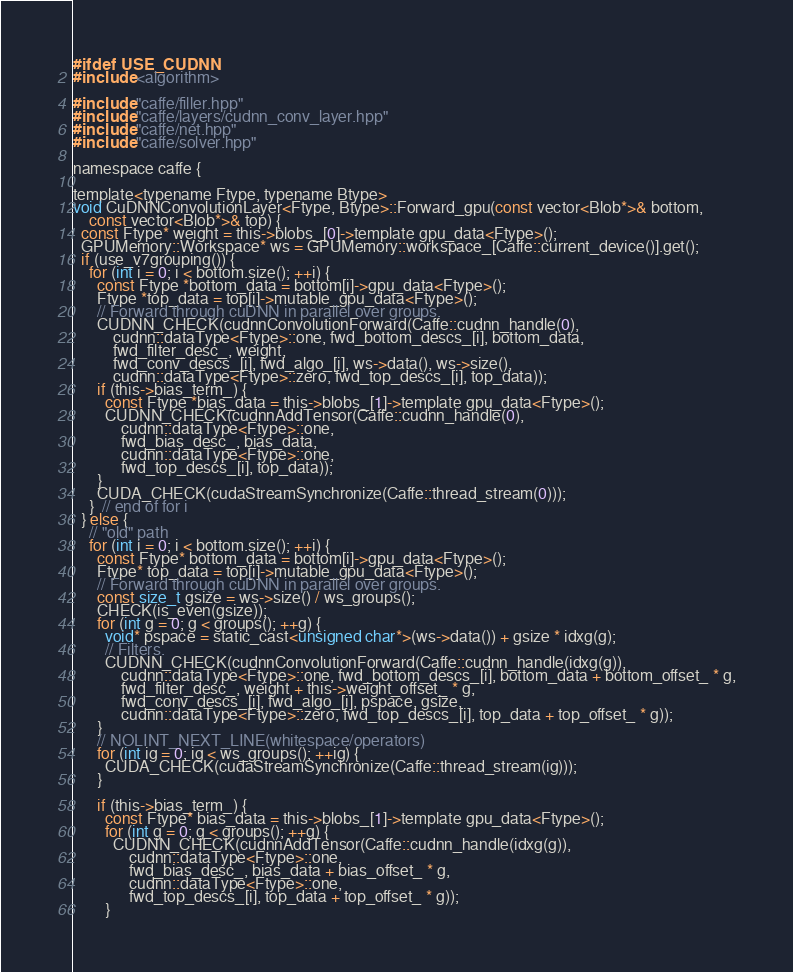Convert code to text. <code><loc_0><loc_0><loc_500><loc_500><_Cuda_>#ifdef USE_CUDNN
#include <algorithm>

#include "caffe/filler.hpp"
#include "caffe/layers/cudnn_conv_layer.hpp"
#include "caffe/net.hpp"
#include "caffe/solver.hpp"

namespace caffe {

template<typename Ftype, typename Btype>
void CuDNNConvolutionLayer<Ftype, Btype>::Forward_gpu(const vector<Blob*>& bottom,
    const vector<Blob*>& top) {
  const Ftype* weight = this->blobs_[0]->template gpu_data<Ftype>();
  GPUMemory::Workspace* ws = GPUMemory::workspace_[Caffe::current_device()].get();
  if (use_v7grouping()) {
    for (int i = 0; i < bottom.size(); ++i) {
      const Ftype *bottom_data = bottom[i]->gpu_data<Ftype>();
      Ftype *top_data = top[i]->mutable_gpu_data<Ftype>();
      // Forward through cuDNN in parallel over groups.
      CUDNN_CHECK(cudnnConvolutionForward(Caffe::cudnn_handle(0),
          cudnn::dataType<Ftype>::one, fwd_bottom_descs_[i], bottom_data,
          fwd_filter_desc_, weight,
          fwd_conv_descs_[i], fwd_algo_[i], ws->data(), ws->size(),
          cudnn::dataType<Ftype>::zero, fwd_top_descs_[i], top_data));
      if (this->bias_term_) {
        const Ftype *bias_data = this->blobs_[1]->template gpu_data<Ftype>();
        CUDNN_CHECK(cudnnAddTensor(Caffe::cudnn_handle(0),
            cudnn::dataType<Ftype>::one,
            fwd_bias_desc_, bias_data,
            cudnn::dataType<Ftype>::one,
            fwd_top_descs_[i], top_data));
      }
      CUDA_CHECK(cudaStreamSynchronize(Caffe::thread_stream(0)));
    }  // end of for i
  } else {
    // "old" path
    for (int i = 0; i < bottom.size(); ++i) {
      const Ftype* bottom_data = bottom[i]->gpu_data<Ftype>();
      Ftype* top_data = top[i]->mutable_gpu_data<Ftype>();
      // Forward through cuDNN in parallel over groups.
      const size_t gsize = ws->size() / ws_groups();
      CHECK(is_even(gsize));
      for (int g = 0; g < groups(); ++g) {
        void* pspace = static_cast<unsigned char*>(ws->data()) + gsize * idxg(g);
        // Filters.
        CUDNN_CHECK(cudnnConvolutionForward(Caffe::cudnn_handle(idxg(g)),
            cudnn::dataType<Ftype>::one, fwd_bottom_descs_[i], bottom_data + bottom_offset_ * g,
            fwd_filter_desc_, weight + this->weight_offset_ * g,
            fwd_conv_descs_[i], fwd_algo_[i], pspace, gsize,
            cudnn::dataType<Ftype>::zero, fwd_top_descs_[i], top_data + top_offset_ * g));
      }
      // NOLINT_NEXT_LINE(whitespace/operators)
      for (int ig = 0; ig < ws_groups(); ++ig) {
        CUDA_CHECK(cudaStreamSynchronize(Caffe::thread_stream(ig)));
      }

      if (this->bias_term_) {
        const Ftype* bias_data = this->blobs_[1]->template gpu_data<Ftype>();
        for (int g = 0; g < groups(); ++g) {
          CUDNN_CHECK(cudnnAddTensor(Caffe::cudnn_handle(idxg(g)),
              cudnn::dataType<Ftype>::one,
              fwd_bias_desc_, bias_data + bias_offset_ * g,
              cudnn::dataType<Ftype>::one,
              fwd_top_descs_[i], top_data + top_offset_ * g));
        }</code> 